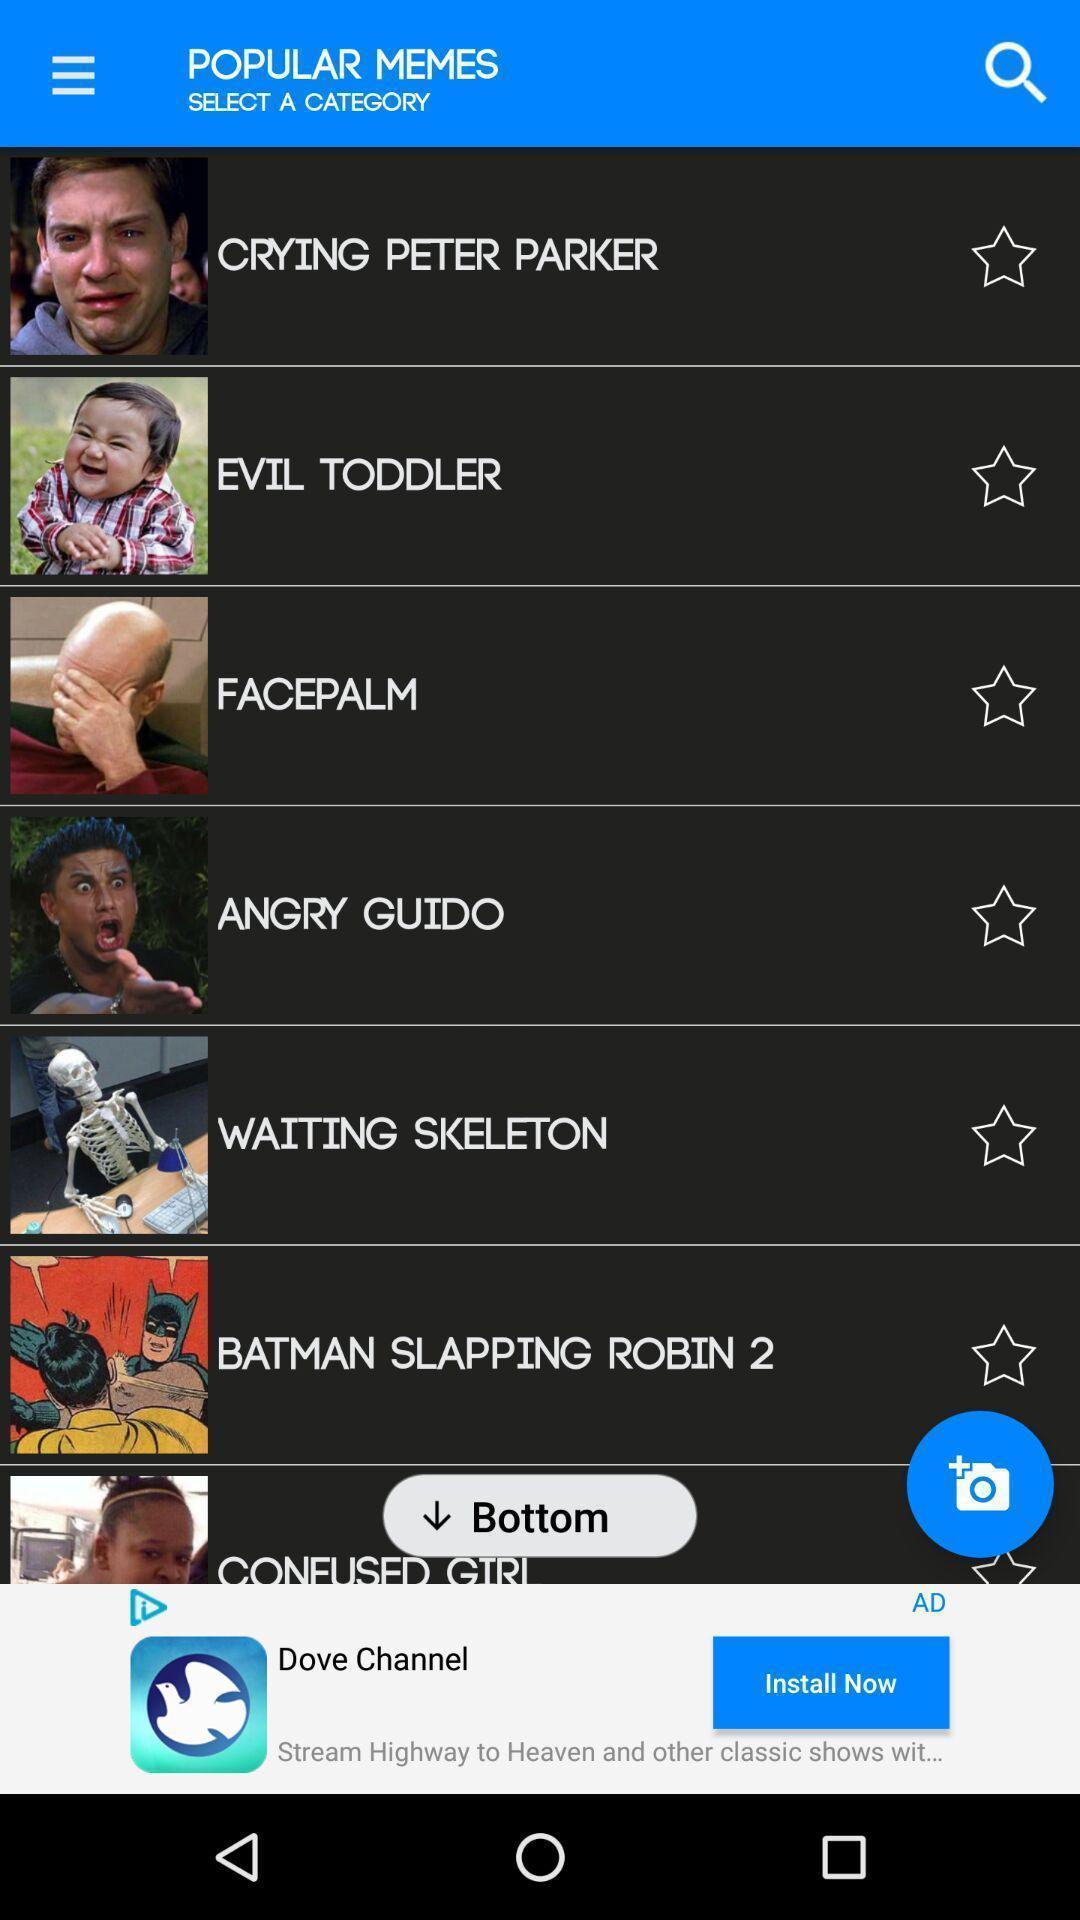What details can you identify in this image? Screen shows list of options in a memes app. 